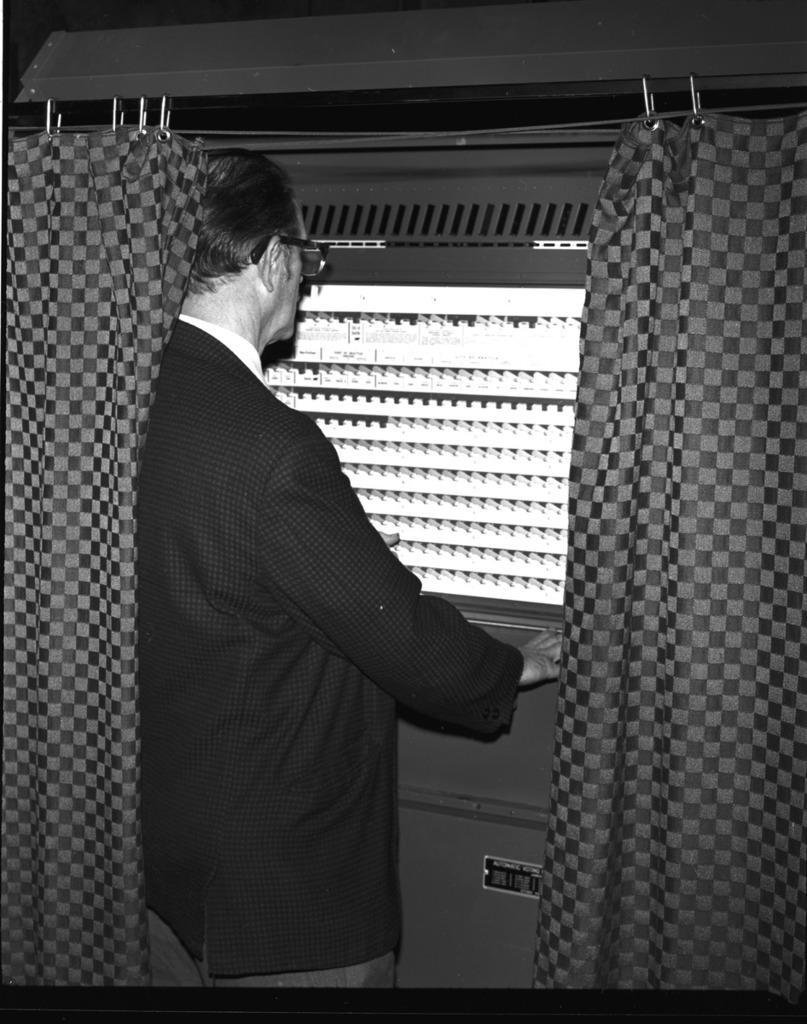Could you give a brief overview of what you see in this image? In this image there is a person standing looking outside through the window, beside the person there are curtains, on the other side of the window there is a cruise ship. 